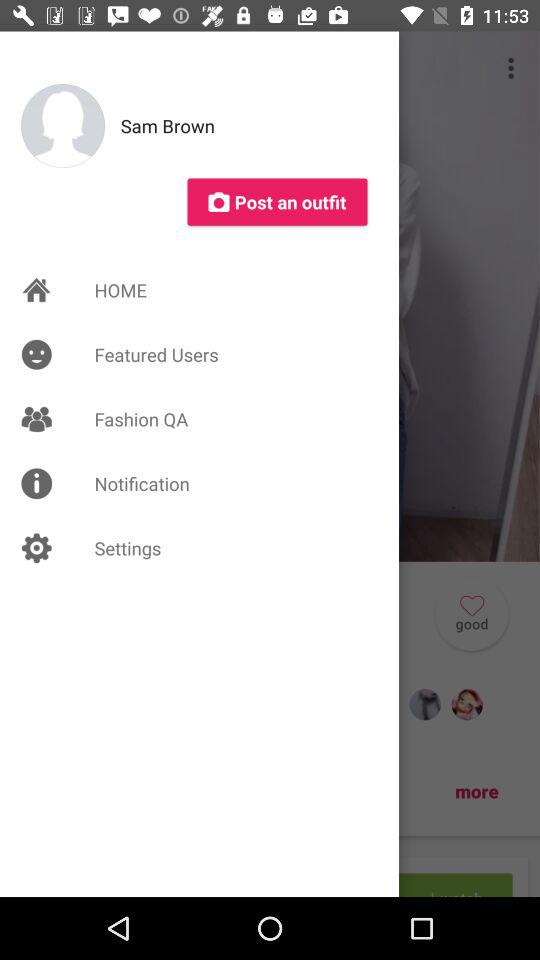What is the name? The name is Sam Brown. 